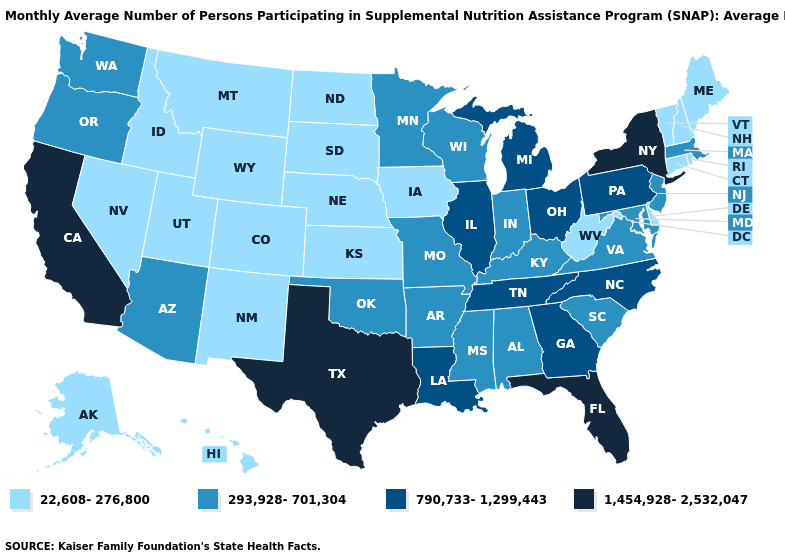Name the states that have a value in the range 293,928-701,304?
Answer briefly. Alabama, Arizona, Arkansas, Indiana, Kentucky, Maryland, Massachusetts, Minnesota, Mississippi, Missouri, New Jersey, Oklahoma, Oregon, South Carolina, Virginia, Washington, Wisconsin. Does Florida have the highest value in the USA?
Quick response, please. Yes. Which states have the lowest value in the USA?
Concise answer only. Alaska, Colorado, Connecticut, Delaware, Hawaii, Idaho, Iowa, Kansas, Maine, Montana, Nebraska, Nevada, New Hampshire, New Mexico, North Dakota, Rhode Island, South Dakota, Utah, Vermont, West Virginia, Wyoming. Among the states that border Ohio , which have the lowest value?
Concise answer only. West Virginia. Which states have the lowest value in the South?
Quick response, please. Delaware, West Virginia. Does Louisiana have the same value as South Carolina?
Answer briefly. No. Does California have the highest value in the West?
Write a very short answer. Yes. Among the states that border Indiana , does Michigan have the lowest value?
Concise answer only. No. Does Nebraska have the lowest value in the USA?
Write a very short answer. Yes. What is the lowest value in the USA?
Keep it brief. 22,608-276,800. Name the states that have a value in the range 22,608-276,800?
Keep it brief. Alaska, Colorado, Connecticut, Delaware, Hawaii, Idaho, Iowa, Kansas, Maine, Montana, Nebraska, Nevada, New Hampshire, New Mexico, North Dakota, Rhode Island, South Dakota, Utah, Vermont, West Virginia, Wyoming. Name the states that have a value in the range 1,454,928-2,532,047?
Quick response, please. California, Florida, New York, Texas. Does New York have the highest value in the USA?
Concise answer only. Yes. Does New York have the highest value in the Northeast?
Give a very brief answer. Yes. Name the states that have a value in the range 1,454,928-2,532,047?
Give a very brief answer. California, Florida, New York, Texas. 